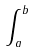Convert formula to latex. <formula><loc_0><loc_0><loc_500><loc_500>\int _ { a } ^ { b }</formula> 